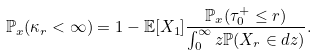<formula> <loc_0><loc_0><loc_500><loc_500>\mathbb { P } _ { x } ( \kappa _ { r } < \infty ) = 1 - \mathbb { E } [ X _ { 1 } ] \frac { \mathbb { P } _ { x } ( \tau _ { 0 } ^ { + } \leq r ) } { \int _ { 0 } ^ { \infty } z \mathbb { P } ( X _ { r } \in d z ) } .</formula> 